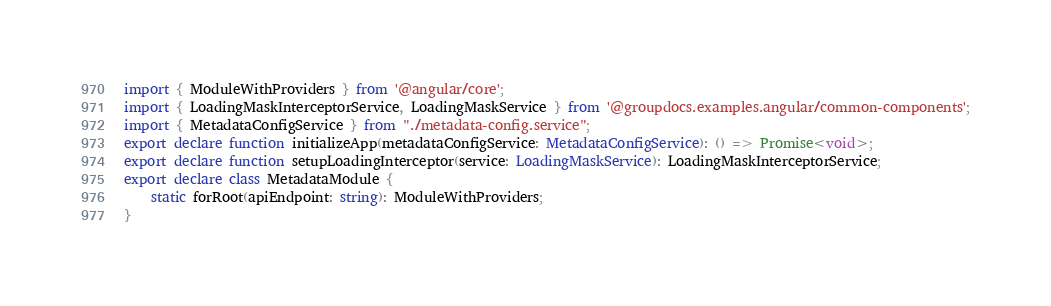<code> <loc_0><loc_0><loc_500><loc_500><_TypeScript_>import { ModuleWithProviders } from '@angular/core';
import { LoadingMaskInterceptorService, LoadingMaskService } from '@groupdocs.examples.angular/common-components';
import { MetadataConfigService } from "./metadata-config.service";
export declare function initializeApp(metadataConfigService: MetadataConfigService): () => Promise<void>;
export declare function setupLoadingInterceptor(service: LoadingMaskService): LoadingMaskInterceptorService;
export declare class MetadataModule {
    static forRoot(apiEndpoint: string): ModuleWithProviders;
}
</code> 